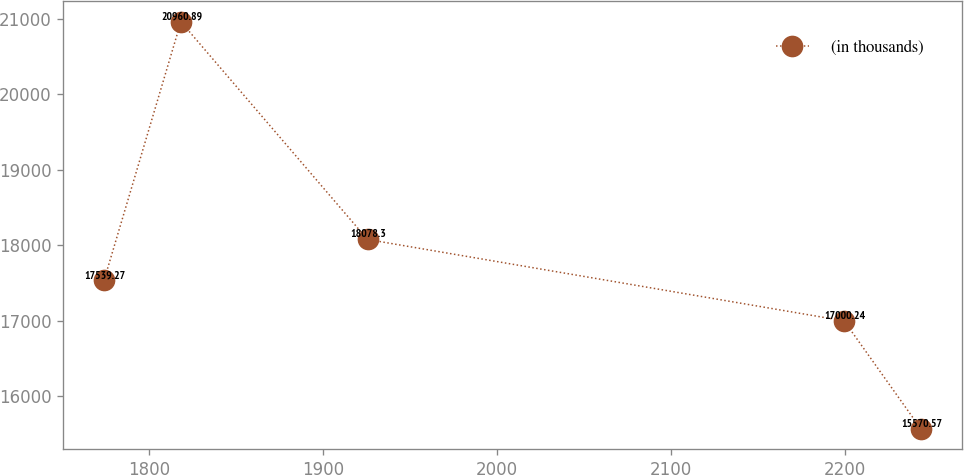Convert chart. <chart><loc_0><loc_0><loc_500><loc_500><line_chart><ecel><fcel>(in thousands)<nl><fcel>1774.23<fcel>17539.3<nl><fcel>1818.36<fcel>20960.9<nl><fcel>1925.63<fcel>18078.3<nl><fcel>2199.58<fcel>17000.2<nl><fcel>2243.71<fcel>15570.6<nl></chart> 